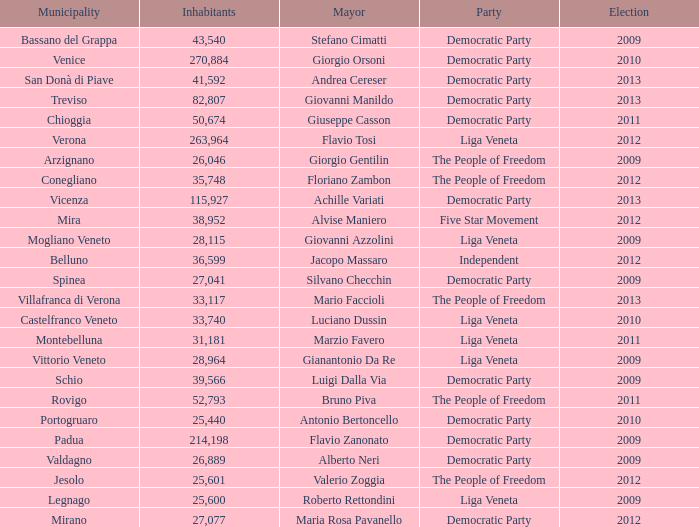In the election earlier than 2012 how many Inhabitants had a Party of five star movement? None. 